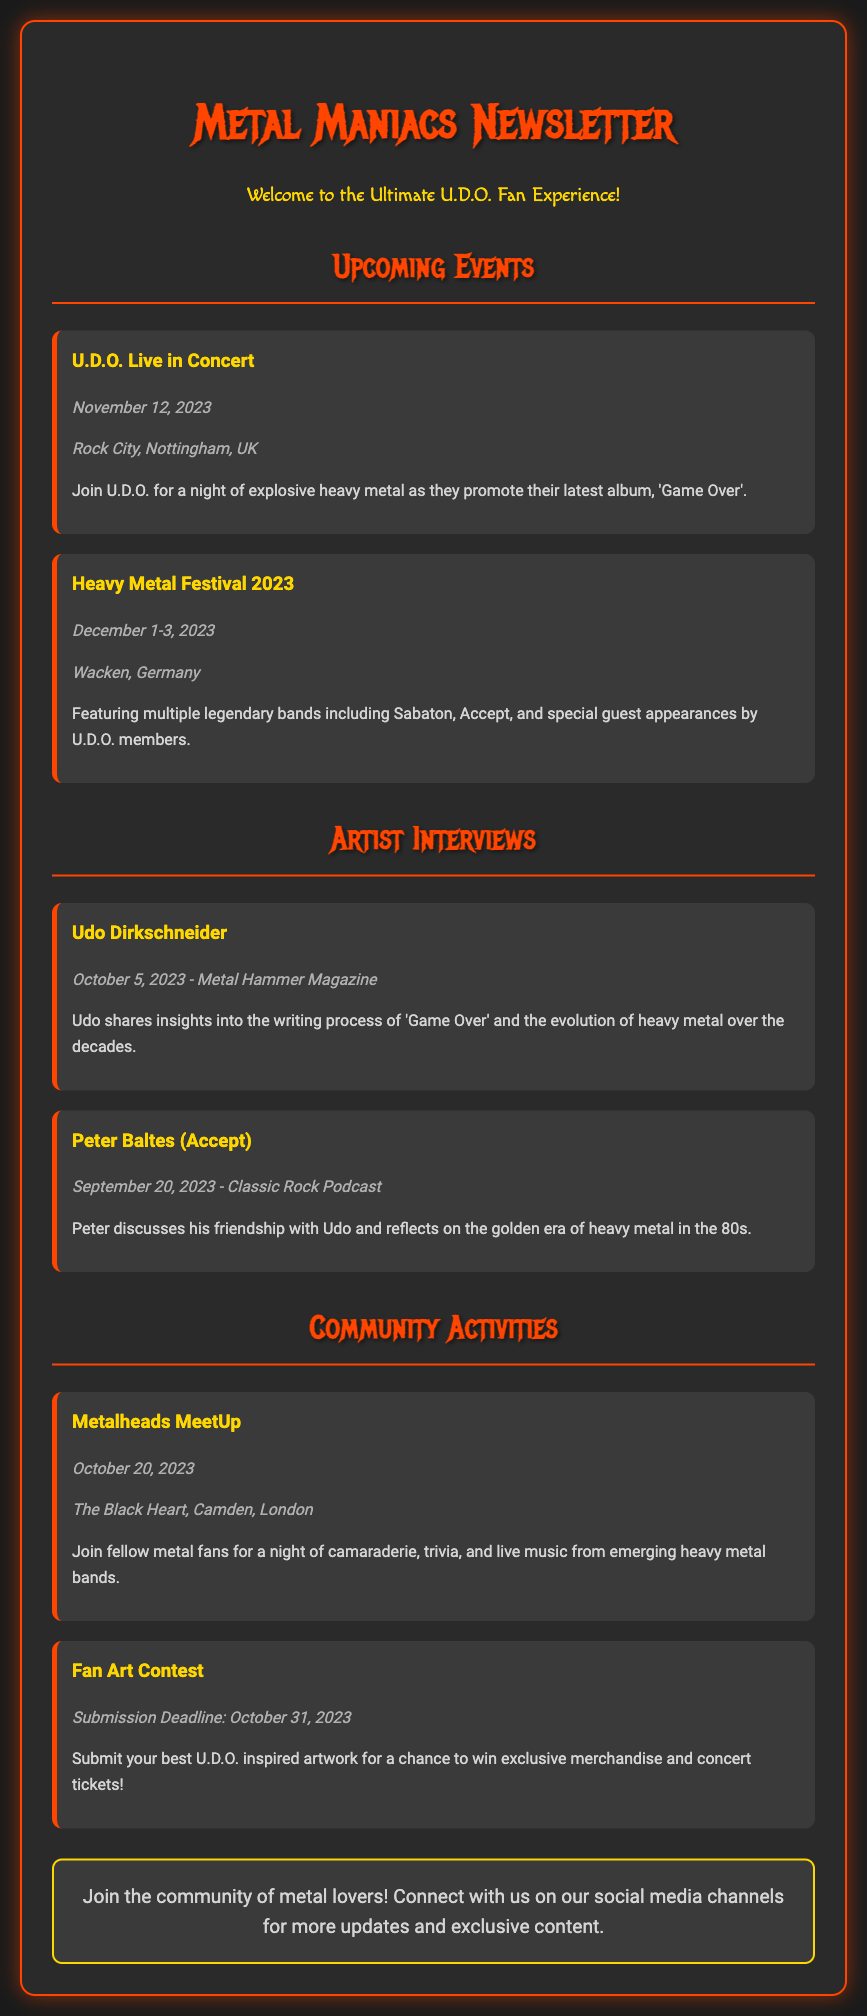What is the date of U.D.O. Live in Concert? The date is mentioned under the event listing for U.D.O. Live in Concert.
Answer: November 12, 2023 Where is the Heavy Metal Festival 2023 being held? The location is specified for the Heavy Metal Festival 2023 in the event section.
Answer: Wacken, Germany Who did the interview with Udo Dirkschneider? The interview is attributed to Metal Hammer Magazine, as stated in the artist interviews section.
Answer: Metal Hammer Magazine What is the submission deadline for the Fan Art Contest? The submission deadline is clearly stated in the community activities section.
Answer: October 31, 2023 What will participants experience at the Metalheads MeetUp? The community activities section describes the event activities participants can expect.
Answer: Trivia and live music How many days is the Heavy Metal Festival 2023? The duration of the festival is specified in the event details.
Answer: 3 days Which artist reflects on the golden era of heavy metal in the 80s? The name is provided in the interviews section for Peter Baltes.
Answer: Peter Baltes What type of music will be featured at the Metalheads MeetUp? The type of music is mentioned under the activities section for the event.
Answer: Live music from emerging heavy metal bands What is the color of the newsletter's border? The document specifies the border color used in its styling.
Answer: #ff4500 